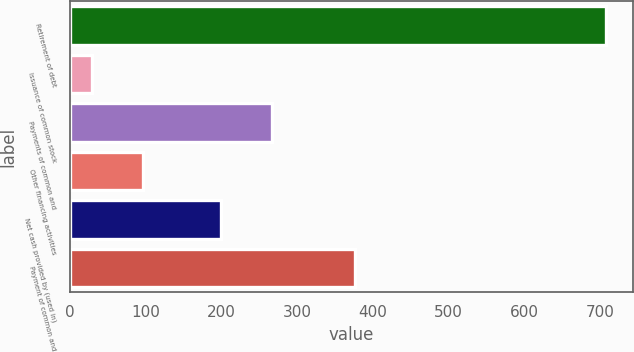Convert chart to OTSL. <chart><loc_0><loc_0><loc_500><loc_500><bar_chart><fcel>Retirement of debt<fcel>Issuance of common stock<fcel>Payments of common and<fcel>Other financing activities<fcel>Net cash provided by (used in)<fcel>Payment of common and<nl><fcel>708<fcel>29<fcel>266.9<fcel>96.9<fcel>199<fcel>376<nl></chart> 